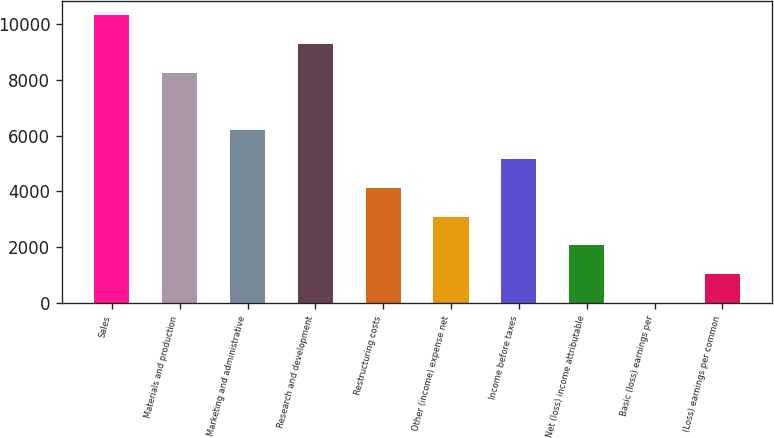Convert chart to OTSL. <chart><loc_0><loc_0><loc_500><loc_500><bar_chart><fcel>Sales<fcel>Materials and production<fcel>Marketing and administrative<fcel>Research and development<fcel>Restructuring costs<fcel>Other (income) expense net<fcel>Income before taxes<fcel>Net (loss) income attributable<fcel>Basic (loss) earnings per<fcel>(Loss) earnings per common<nl><fcel>10325<fcel>8260.02<fcel>6195.02<fcel>9292.52<fcel>4130.02<fcel>3097.52<fcel>5162.52<fcel>2065.02<fcel>0.02<fcel>1032.52<nl></chart> 